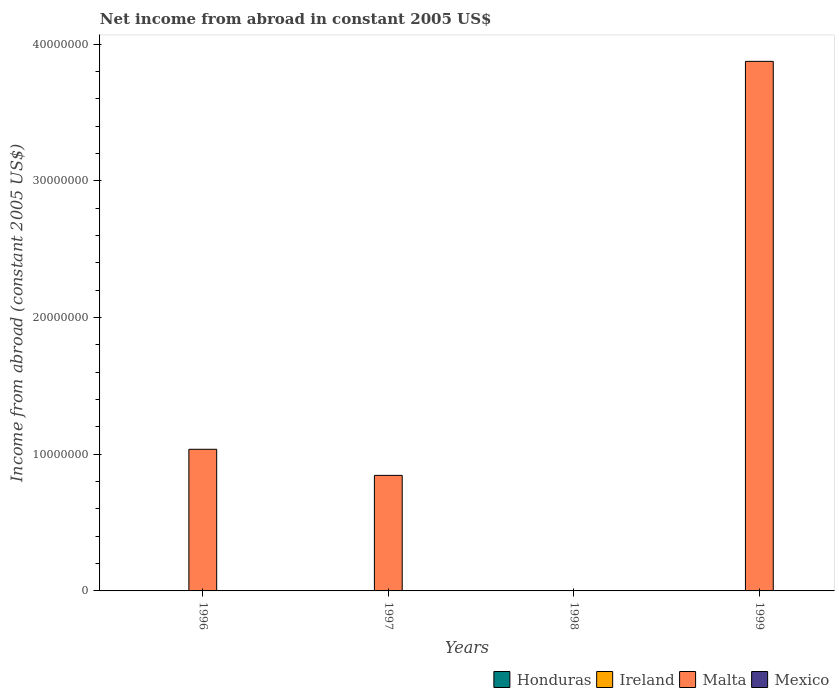How many different coloured bars are there?
Give a very brief answer. 1. Are the number of bars per tick equal to the number of legend labels?
Your response must be concise. No. Are the number of bars on each tick of the X-axis equal?
Give a very brief answer. No. How many bars are there on the 1st tick from the right?
Keep it short and to the point. 1. In how many cases, is the number of bars for a given year not equal to the number of legend labels?
Provide a short and direct response. 4. What is the net income from abroad in Malta in 1999?
Provide a short and direct response. 3.87e+07. Across all years, what is the maximum net income from abroad in Malta?
Your answer should be compact. 3.87e+07. What is the difference between the net income from abroad in Malta in 1996 and that in 1999?
Make the answer very short. -2.84e+07. What is the difference between the net income from abroad in Ireland in 1997 and the net income from abroad in Malta in 1999?
Provide a short and direct response. -3.87e+07. In how many years, is the net income from abroad in Mexico greater than 28000000 US$?
Make the answer very short. 0. What is the difference between the highest and the second highest net income from abroad in Malta?
Offer a very short reply. 2.84e+07. What is the difference between the highest and the lowest net income from abroad in Malta?
Offer a terse response. 3.87e+07. Are all the bars in the graph horizontal?
Ensure brevity in your answer.  No. How many years are there in the graph?
Keep it short and to the point. 4. What is the difference between two consecutive major ticks on the Y-axis?
Make the answer very short. 1.00e+07. How are the legend labels stacked?
Provide a short and direct response. Horizontal. What is the title of the graph?
Make the answer very short. Net income from abroad in constant 2005 US$. What is the label or title of the X-axis?
Offer a terse response. Years. What is the label or title of the Y-axis?
Ensure brevity in your answer.  Income from abroad (constant 2005 US$). What is the Income from abroad (constant 2005 US$) of Ireland in 1996?
Keep it short and to the point. 0. What is the Income from abroad (constant 2005 US$) of Malta in 1996?
Offer a terse response. 1.04e+07. What is the Income from abroad (constant 2005 US$) in Mexico in 1996?
Make the answer very short. 0. What is the Income from abroad (constant 2005 US$) of Honduras in 1997?
Ensure brevity in your answer.  0. What is the Income from abroad (constant 2005 US$) of Ireland in 1997?
Your answer should be very brief. 0. What is the Income from abroad (constant 2005 US$) in Malta in 1997?
Make the answer very short. 8.45e+06. What is the Income from abroad (constant 2005 US$) in Ireland in 1998?
Provide a short and direct response. 0. What is the Income from abroad (constant 2005 US$) in Malta in 1998?
Keep it short and to the point. 0. What is the Income from abroad (constant 2005 US$) in Mexico in 1998?
Provide a succinct answer. 0. What is the Income from abroad (constant 2005 US$) in Malta in 1999?
Your answer should be very brief. 3.87e+07. What is the Income from abroad (constant 2005 US$) in Mexico in 1999?
Offer a very short reply. 0. Across all years, what is the maximum Income from abroad (constant 2005 US$) of Malta?
Offer a very short reply. 3.87e+07. What is the total Income from abroad (constant 2005 US$) in Honduras in the graph?
Your response must be concise. 0. What is the total Income from abroad (constant 2005 US$) of Malta in the graph?
Make the answer very short. 5.76e+07. What is the difference between the Income from abroad (constant 2005 US$) of Malta in 1996 and that in 1997?
Provide a short and direct response. 1.91e+06. What is the difference between the Income from abroad (constant 2005 US$) in Malta in 1996 and that in 1999?
Your answer should be very brief. -2.84e+07. What is the difference between the Income from abroad (constant 2005 US$) of Malta in 1997 and that in 1999?
Keep it short and to the point. -3.03e+07. What is the average Income from abroad (constant 2005 US$) of Honduras per year?
Your answer should be very brief. 0. What is the average Income from abroad (constant 2005 US$) in Malta per year?
Provide a short and direct response. 1.44e+07. What is the ratio of the Income from abroad (constant 2005 US$) in Malta in 1996 to that in 1997?
Provide a short and direct response. 1.23. What is the ratio of the Income from abroad (constant 2005 US$) of Malta in 1996 to that in 1999?
Offer a terse response. 0.27. What is the ratio of the Income from abroad (constant 2005 US$) of Malta in 1997 to that in 1999?
Keep it short and to the point. 0.22. What is the difference between the highest and the second highest Income from abroad (constant 2005 US$) of Malta?
Provide a succinct answer. 2.84e+07. What is the difference between the highest and the lowest Income from abroad (constant 2005 US$) of Malta?
Your answer should be compact. 3.87e+07. 